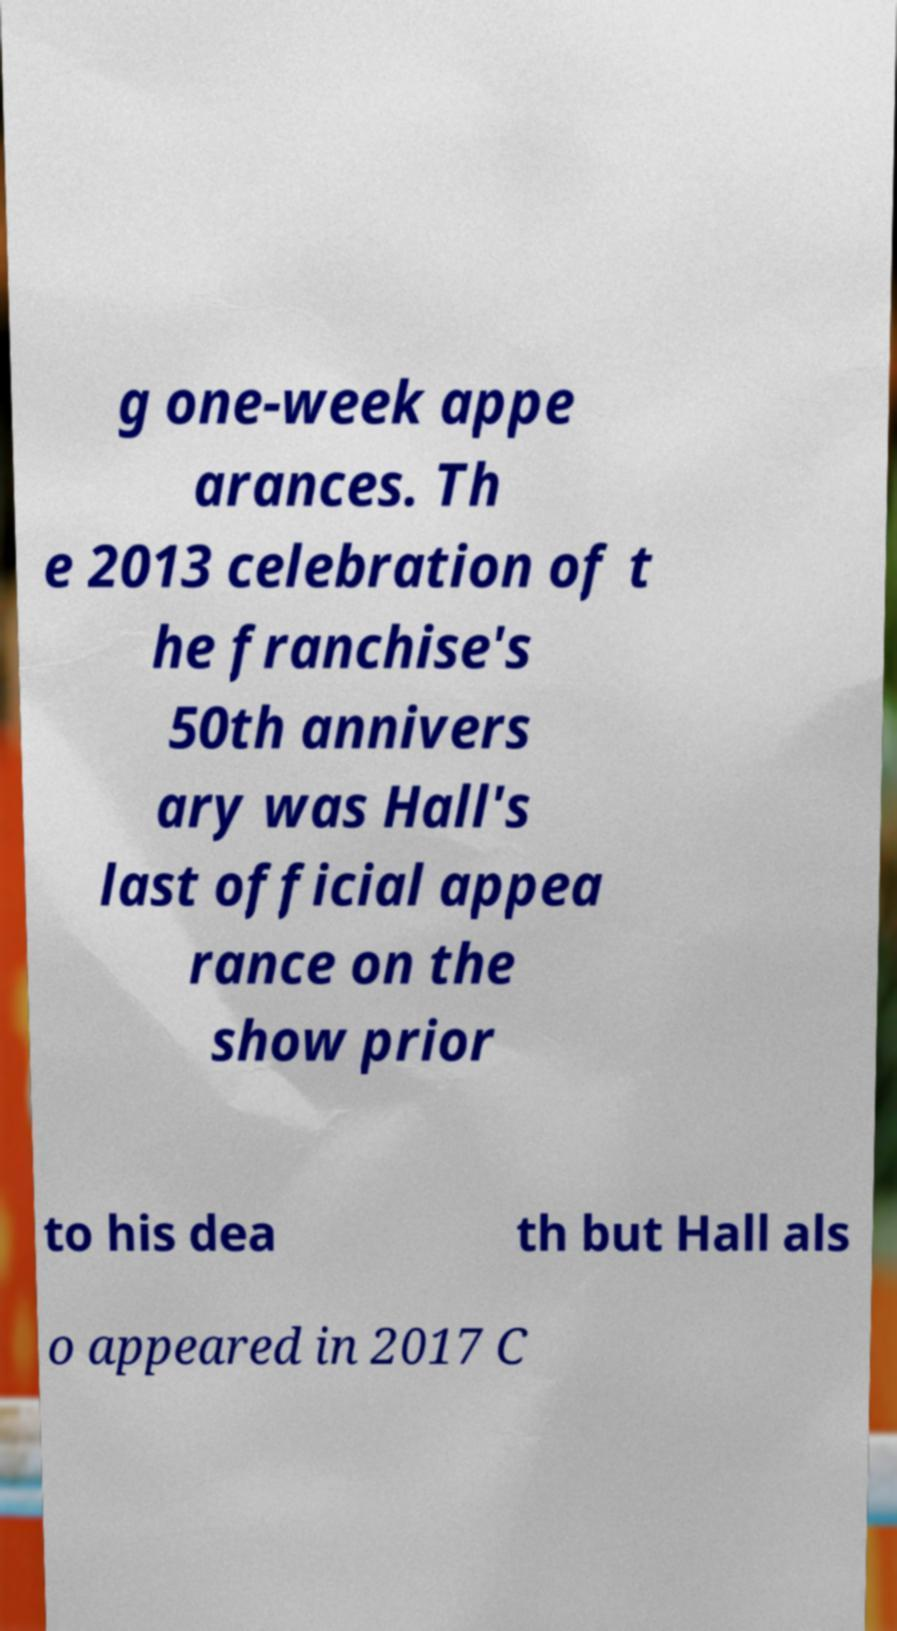I need the written content from this picture converted into text. Can you do that? g one-week appe arances. Th e 2013 celebration of t he franchise's 50th annivers ary was Hall's last official appea rance on the show prior to his dea th but Hall als o appeared in 2017 C 